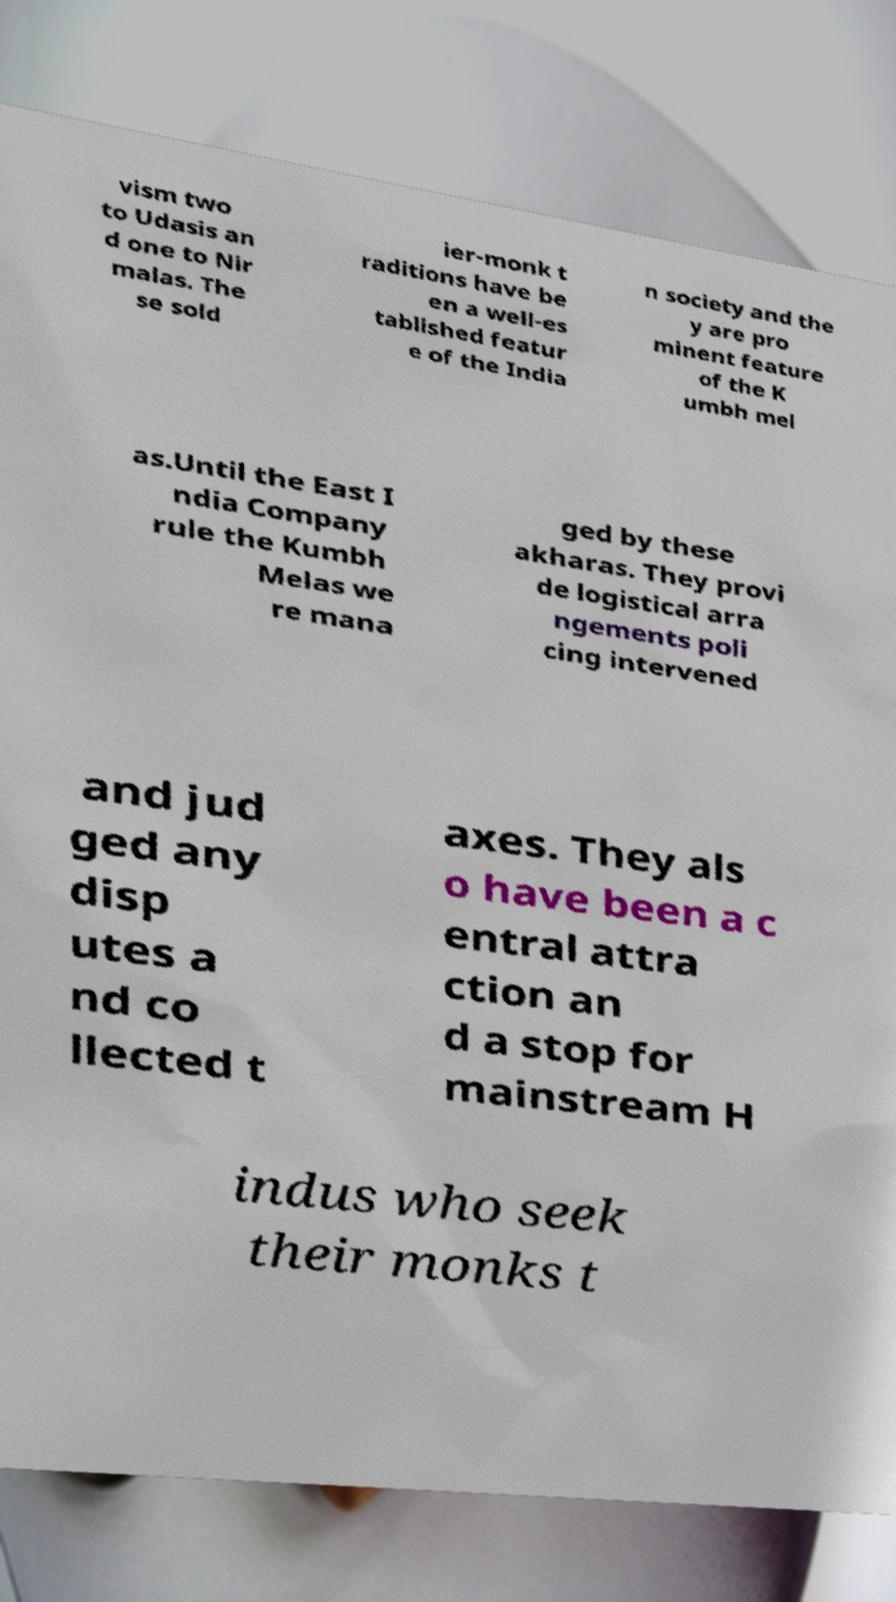Could you assist in decoding the text presented in this image and type it out clearly? vism two to Udasis an d one to Nir malas. The se sold ier-monk t raditions have be en a well-es tablished featur e of the India n society and the y are pro minent feature of the K umbh mel as.Until the East I ndia Company rule the Kumbh Melas we re mana ged by these akharas. They provi de logistical arra ngements poli cing intervened and jud ged any disp utes a nd co llected t axes. They als o have been a c entral attra ction an d a stop for mainstream H indus who seek their monks t 